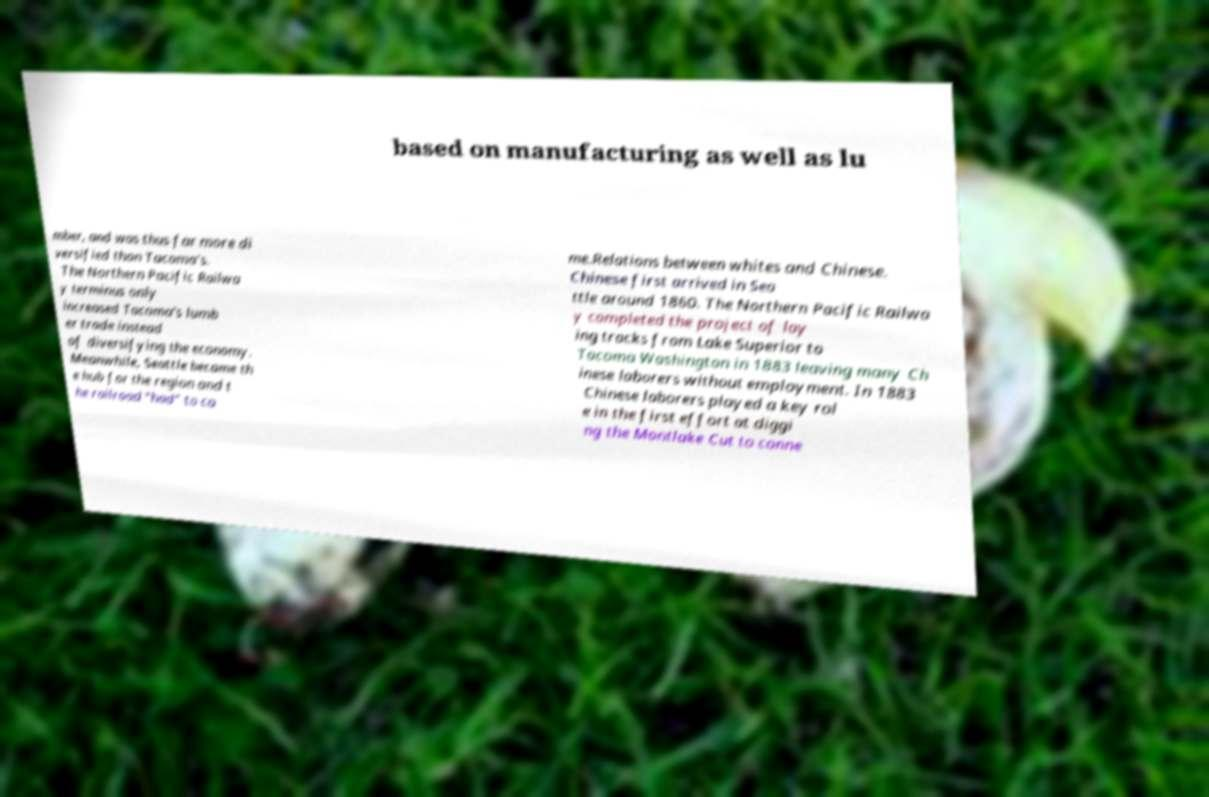What messages or text are displayed in this image? I need them in a readable, typed format. based on manufacturing as well as lu mber, and was thus far more di versified than Tacoma's. The Northern Pacific Railwa y terminus only increased Tacoma's lumb er trade instead of diversifying the economy. Meanwhile, Seattle became th e hub for the region and t he railroad "had" to co me.Relations between whites and Chinese. Chinese first arrived in Sea ttle around 1860. The Northern Pacific Railwa y completed the project of lay ing tracks from Lake Superior to Tacoma Washington in 1883 leaving many Ch inese laborers without employment. In 1883 Chinese laborers played a key rol e in the first effort at diggi ng the Montlake Cut to conne 